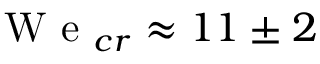<formula> <loc_0><loc_0><loc_500><loc_500>W e _ { c r } \approx 1 1 \pm 2</formula> 